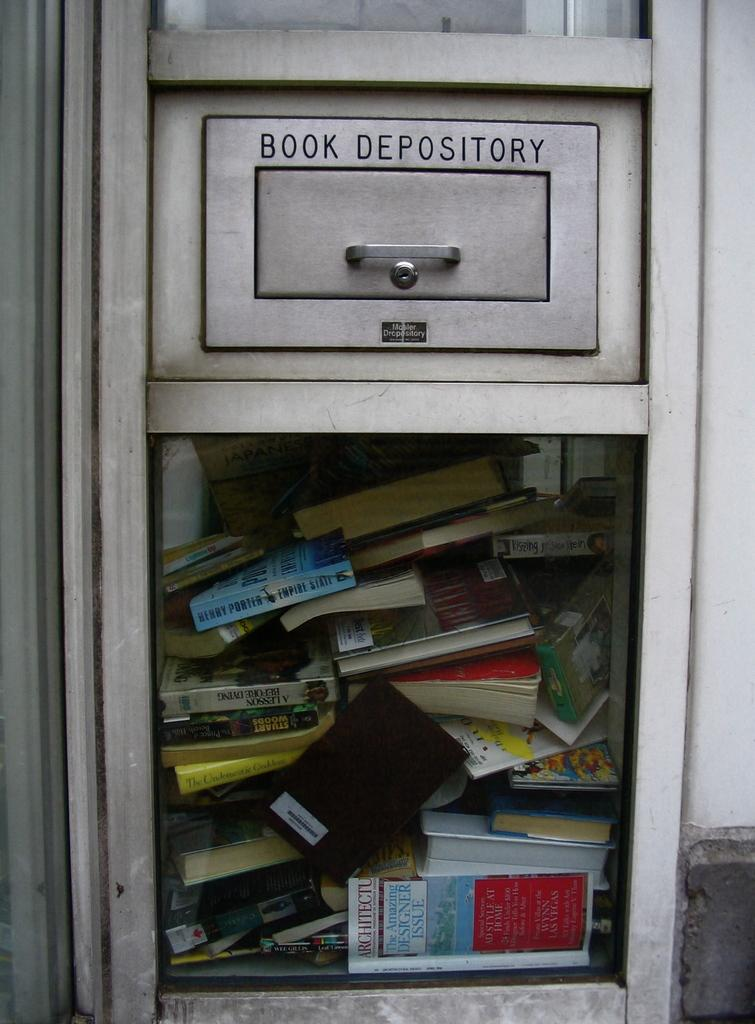<image>
Present a compact description of the photo's key features. Book depository full of different kinds of books. 